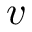<formula> <loc_0><loc_0><loc_500><loc_500>v</formula> 